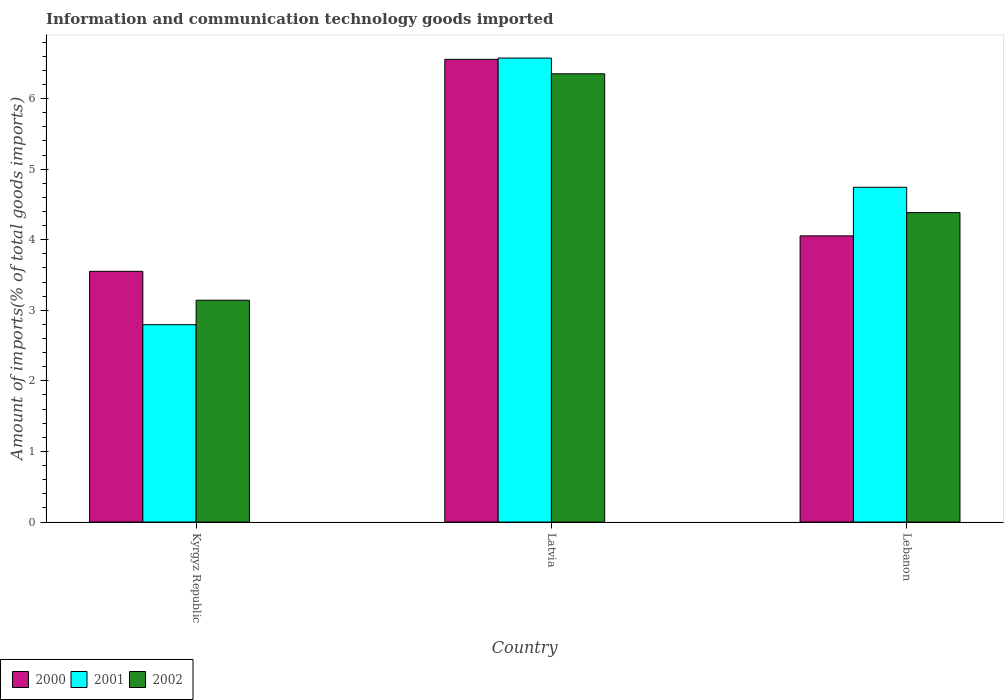Are the number of bars per tick equal to the number of legend labels?
Make the answer very short. Yes. How many bars are there on the 3rd tick from the left?
Your answer should be compact. 3. How many bars are there on the 1st tick from the right?
Offer a terse response. 3. What is the label of the 1st group of bars from the left?
Provide a succinct answer. Kyrgyz Republic. What is the amount of goods imported in 2001 in Lebanon?
Your response must be concise. 4.74. Across all countries, what is the maximum amount of goods imported in 2001?
Your answer should be very brief. 6.57. Across all countries, what is the minimum amount of goods imported in 2000?
Your answer should be very brief. 3.55. In which country was the amount of goods imported in 2001 maximum?
Your response must be concise. Latvia. In which country was the amount of goods imported in 2002 minimum?
Keep it short and to the point. Kyrgyz Republic. What is the total amount of goods imported in 2000 in the graph?
Your answer should be very brief. 14.16. What is the difference between the amount of goods imported in 2001 in Latvia and that in Lebanon?
Offer a terse response. 1.83. What is the difference between the amount of goods imported in 2001 in Kyrgyz Republic and the amount of goods imported in 2002 in Latvia?
Your answer should be very brief. -3.55. What is the average amount of goods imported in 2000 per country?
Your answer should be very brief. 4.72. What is the difference between the amount of goods imported of/in 2000 and amount of goods imported of/in 2001 in Latvia?
Give a very brief answer. -0.02. What is the ratio of the amount of goods imported in 2002 in Latvia to that in Lebanon?
Provide a succinct answer. 1.45. What is the difference between the highest and the second highest amount of goods imported in 2002?
Your answer should be very brief. -1.24. What is the difference between the highest and the lowest amount of goods imported in 2002?
Your answer should be very brief. 3.21. What does the 1st bar from the right in Kyrgyz Republic represents?
Your response must be concise. 2002. Is it the case that in every country, the sum of the amount of goods imported in 2002 and amount of goods imported in 2001 is greater than the amount of goods imported in 2000?
Your answer should be very brief. Yes. How many bars are there?
Provide a short and direct response. 9. What is the difference between two consecutive major ticks on the Y-axis?
Give a very brief answer. 1. Where does the legend appear in the graph?
Provide a short and direct response. Bottom left. How many legend labels are there?
Provide a short and direct response. 3. How are the legend labels stacked?
Ensure brevity in your answer.  Horizontal. What is the title of the graph?
Give a very brief answer. Information and communication technology goods imported. Does "1996" appear as one of the legend labels in the graph?
Your answer should be compact. No. What is the label or title of the Y-axis?
Offer a terse response. Amount of imports(% of total goods imports). What is the Amount of imports(% of total goods imports) of 2000 in Kyrgyz Republic?
Your response must be concise. 3.55. What is the Amount of imports(% of total goods imports) of 2001 in Kyrgyz Republic?
Keep it short and to the point. 2.8. What is the Amount of imports(% of total goods imports) of 2002 in Kyrgyz Republic?
Ensure brevity in your answer.  3.14. What is the Amount of imports(% of total goods imports) of 2000 in Latvia?
Ensure brevity in your answer.  6.56. What is the Amount of imports(% of total goods imports) of 2001 in Latvia?
Your answer should be compact. 6.57. What is the Amount of imports(% of total goods imports) of 2002 in Latvia?
Offer a terse response. 6.35. What is the Amount of imports(% of total goods imports) in 2000 in Lebanon?
Your answer should be very brief. 4.05. What is the Amount of imports(% of total goods imports) in 2001 in Lebanon?
Provide a short and direct response. 4.74. What is the Amount of imports(% of total goods imports) in 2002 in Lebanon?
Your answer should be compact. 4.38. Across all countries, what is the maximum Amount of imports(% of total goods imports) of 2000?
Your answer should be compact. 6.56. Across all countries, what is the maximum Amount of imports(% of total goods imports) of 2001?
Keep it short and to the point. 6.57. Across all countries, what is the maximum Amount of imports(% of total goods imports) in 2002?
Give a very brief answer. 6.35. Across all countries, what is the minimum Amount of imports(% of total goods imports) in 2000?
Keep it short and to the point. 3.55. Across all countries, what is the minimum Amount of imports(% of total goods imports) in 2001?
Provide a short and direct response. 2.8. Across all countries, what is the minimum Amount of imports(% of total goods imports) of 2002?
Give a very brief answer. 3.14. What is the total Amount of imports(% of total goods imports) in 2000 in the graph?
Offer a very short reply. 14.16. What is the total Amount of imports(% of total goods imports) of 2001 in the graph?
Provide a succinct answer. 14.11. What is the total Amount of imports(% of total goods imports) in 2002 in the graph?
Make the answer very short. 13.88. What is the difference between the Amount of imports(% of total goods imports) of 2000 in Kyrgyz Republic and that in Latvia?
Provide a short and direct response. -3. What is the difference between the Amount of imports(% of total goods imports) of 2001 in Kyrgyz Republic and that in Latvia?
Your answer should be compact. -3.78. What is the difference between the Amount of imports(% of total goods imports) of 2002 in Kyrgyz Republic and that in Latvia?
Your response must be concise. -3.21. What is the difference between the Amount of imports(% of total goods imports) of 2000 in Kyrgyz Republic and that in Lebanon?
Provide a short and direct response. -0.5. What is the difference between the Amount of imports(% of total goods imports) in 2001 in Kyrgyz Republic and that in Lebanon?
Offer a very short reply. -1.95. What is the difference between the Amount of imports(% of total goods imports) in 2002 in Kyrgyz Republic and that in Lebanon?
Your answer should be very brief. -1.24. What is the difference between the Amount of imports(% of total goods imports) of 2000 in Latvia and that in Lebanon?
Offer a very short reply. 2.5. What is the difference between the Amount of imports(% of total goods imports) of 2001 in Latvia and that in Lebanon?
Your answer should be compact. 1.83. What is the difference between the Amount of imports(% of total goods imports) in 2002 in Latvia and that in Lebanon?
Keep it short and to the point. 1.97. What is the difference between the Amount of imports(% of total goods imports) in 2000 in Kyrgyz Republic and the Amount of imports(% of total goods imports) in 2001 in Latvia?
Keep it short and to the point. -3.02. What is the difference between the Amount of imports(% of total goods imports) in 2000 in Kyrgyz Republic and the Amount of imports(% of total goods imports) in 2002 in Latvia?
Your response must be concise. -2.8. What is the difference between the Amount of imports(% of total goods imports) in 2001 in Kyrgyz Republic and the Amount of imports(% of total goods imports) in 2002 in Latvia?
Provide a succinct answer. -3.55. What is the difference between the Amount of imports(% of total goods imports) of 2000 in Kyrgyz Republic and the Amount of imports(% of total goods imports) of 2001 in Lebanon?
Your answer should be very brief. -1.19. What is the difference between the Amount of imports(% of total goods imports) of 2000 in Kyrgyz Republic and the Amount of imports(% of total goods imports) of 2002 in Lebanon?
Make the answer very short. -0.83. What is the difference between the Amount of imports(% of total goods imports) of 2001 in Kyrgyz Republic and the Amount of imports(% of total goods imports) of 2002 in Lebanon?
Your answer should be compact. -1.59. What is the difference between the Amount of imports(% of total goods imports) of 2000 in Latvia and the Amount of imports(% of total goods imports) of 2001 in Lebanon?
Give a very brief answer. 1.81. What is the difference between the Amount of imports(% of total goods imports) in 2000 in Latvia and the Amount of imports(% of total goods imports) in 2002 in Lebanon?
Provide a succinct answer. 2.17. What is the difference between the Amount of imports(% of total goods imports) of 2001 in Latvia and the Amount of imports(% of total goods imports) of 2002 in Lebanon?
Make the answer very short. 2.19. What is the average Amount of imports(% of total goods imports) of 2000 per country?
Your response must be concise. 4.72. What is the average Amount of imports(% of total goods imports) in 2001 per country?
Your answer should be compact. 4.7. What is the average Amount of imports(% of total goods imports) of 2002 per country?
Make the answer very short. 4.63. What is the difference between the Amount of imports(% of total goods imports) in 2000 and Amount of imports(% of total goods imports) in 2001 in Kyrgyz Republic?
Make the answer very short. 0.76. What is the difference between the Amount of imports(% of total goods imports) in 2000 and Amount of imports(% of total goods imports) in 2002 in Kyrgyz Republic?
Make the answer very short. 0.41. What is the difference between the Amount of imports(% of total goods imports) of 2001 and Amount of imports(% of total goods imports) of 2002 in Kyrgyz Republic?
Your answer should be very brief. -0.35. What is the difference between the Amount of imports(% of total goods imports) in 2000 and Amount of imports(% of total goods imports) in 2001 in Latvia?
Give a very brief answer. -0.02. What is the difference between the Amount of imports(% of total goods imports) in 2000 and Amount of imports(% of total goods imports) in 2002 in Latvia?
Make the answer very short. 0.2. What is the difference between the Amount of imports(% of total goods imports) of 2001 and Amount of imports(% of total goods imports) of 2002 in Latvia?
Give a very brief answer. 0.22. What is the difference between the Amount of imports(% of total goods imports) in 2000 and Amount of imports(% of total goods imports) in 2001 in Lebanon?
Your response must be concise. -0.69. What is the difference between the Amount of imports(% of total goods imports) of 2000 and Amount of imports(% of total goods imports) of 2002 in Lebanon?
Ensure brevity in your answer.  -0.33. What is the difference between the Amount of imports(% of total goods imports) of 2001 and Amount of imports(% of total goods imports) of 2002 in Lebanon?
Offer a terse response. 0.36. What is the ratio of the Amount of imports(% of total goods imports) in 2000 in Kyrgyz Republic to that in Latvia?
Offer a terse response. 0.54. What is the ratio of the Amount of imports(% of total goods imports) in 2001 in Kyrgyz Republic to that in Latvia?
Ensure brevity in your answer.  0.43. What is the ratio of the Amount of imports(% of total goods imports) of 2002 in Kyrgyz Republic to that in Latvia?
Your response must be concise. 0.49. What is the ratio of the Amount of imports(% of total goods imports) of 2000 in Kyrgyz Republic to that in Lebanon?
Offer a terse response. 0.88. What is the ratio of the Amount of imports(% of total goods imports) of 2001 in Kyrgyz Republic to that in Lebanon?
Give a very brief answer. 0.59. What is the ratio of the Amount of imports(% of total goods imports) in 2002 in Kyrgyz Republic to that in Lebanon?
Your response must be concise. 0.72. What is the ratio of the Amount of imports(% of total goods imports) of 2000 in Latvia to that in Lebanon?
Offer a very short reply. 1.62. What is the ratio of the Amount of imports(% of total goods imports) in 2001 in Latvia to that in Lebanon?
Make the answer very short. 1.39. What is the ratio of the Amount of imports(% of total goods imports) in 2002 in Latvia to that in Lebanon?
Your answer should be very brief. 1.45. What is the difference between the highest and the second highest Amount of imports(% of total goods imports) in 2000?
Keep it short and to the point. 2.5. What is the difference between the highest and the second highest Amount of imports(% of total goods imports) of 2001?
Provide a short and direct response. 1.83. What is the difference between the highest and the second highest Amount of imports(% of total goods imports) of 2002?
Provide a short and direct response. 1.97. What is the difference between the highest and the lowest Amount of imports(% of total goods imports) of 2000?
Your answer should be very brief. 3. What is the difference between the highest and the lowest Amount of imports(% of total goods imports) in 2001?
Offer a very short reply. 3.78. What is the difference between the highest and the lowest Amount of imports(% of total goods imports) in 2002?
Provide a short and direct response. 3.21. 